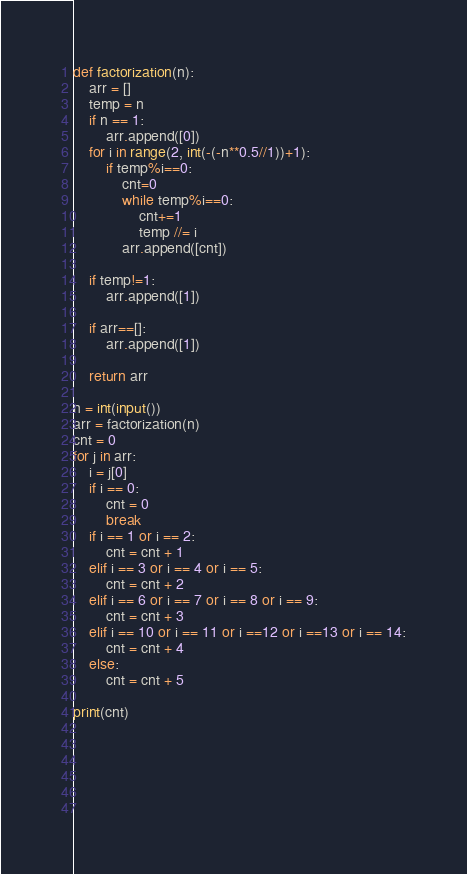<code> <loc_0><loc_0><loc_500><loc_500><_Python_>def factorization(n):
    arr = []
    temp = n
    if n == 1:
        arr.append([0])
    for i in range(2, int(-(-n**0.5//1))+1):
        if temp%i==0:
            cnt=0
            while temp%i==0:
                cnt+=1
                temp //= i
            arr.append([cnt])

    if temp!=1:
        arr.append([1])

    if arr==[]:
        arr.append([1])

    return arr

n = int(input())
arr = factorization(n)
cnt = 0
for j in arr:
    i = j[0]
    if i == 0:
        cnt = 0
        break
    if i == 1 or i == 2:
        cnt = cnt + 1
    elif i == 3 or i == 4 or i == 5:
        cnt = cnt + 2
    elif i == 6 or i == 7 or i == 8 or i == 9:
        cnt = cnt + 3
    elif i == 10 or i == 11 or i ==12 or i ==13 or i == 14:
        cnt = cnt + 4
    else:
        cnt = cnt + 5
        
print(cnt)
    
    
    
    
    
        </code> 